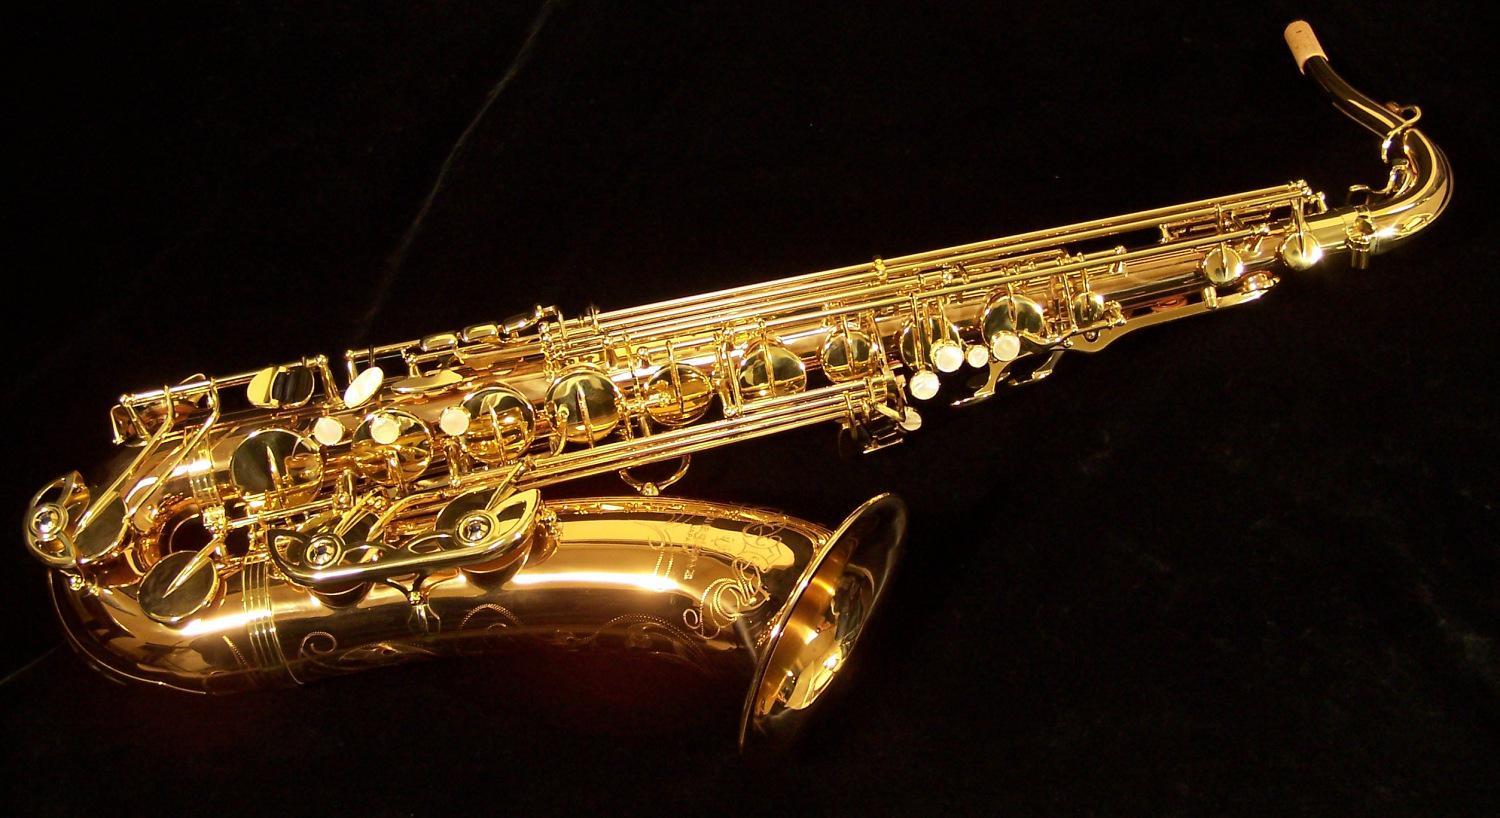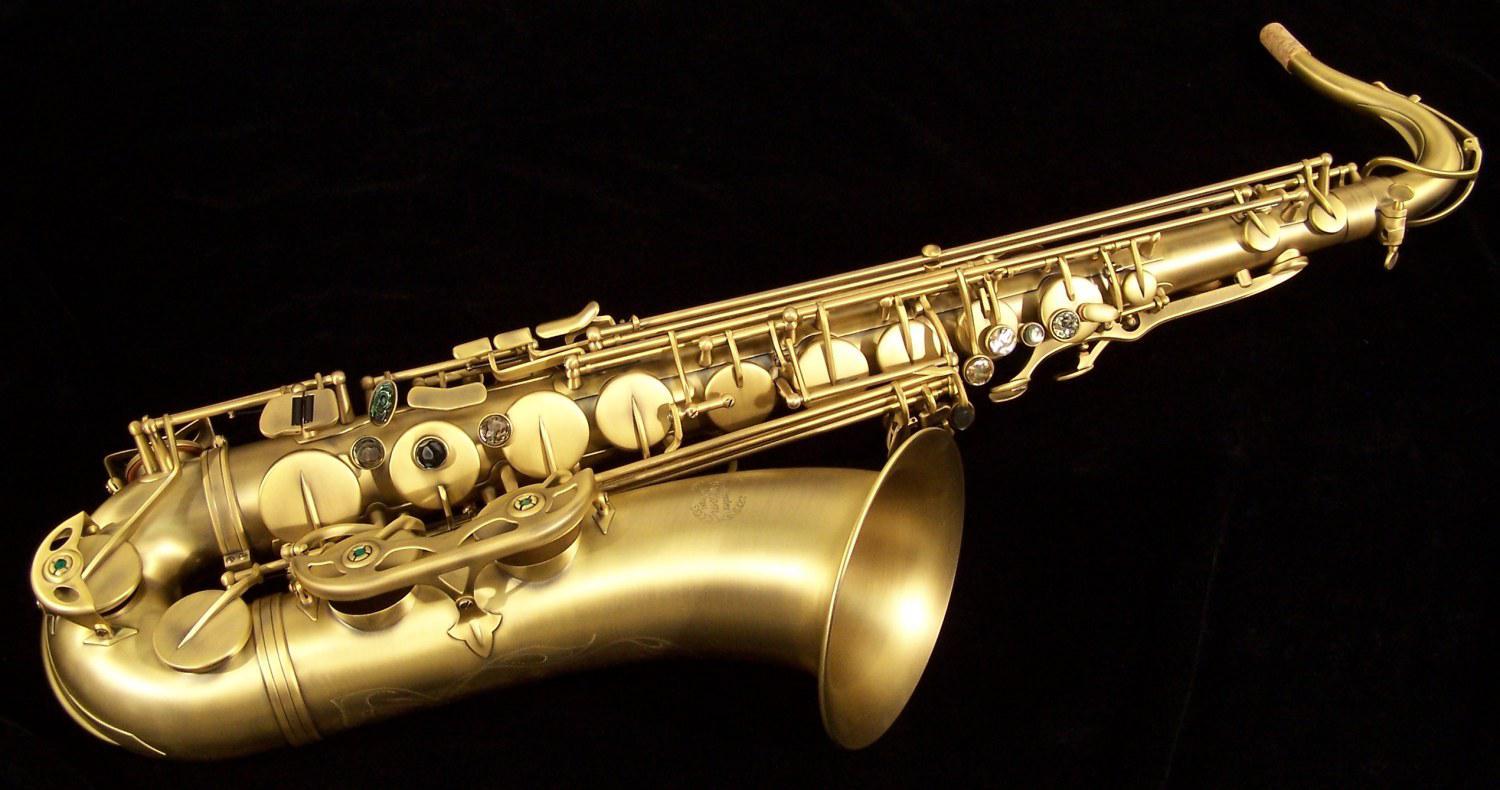The first image is the image on the left, the second image is the image on the right. Examine the images to the left and right. Is the description "Exactly two saxophones the same style, color, and size are positioned at the same angle, horizontal with their bells to the front." accurate? Answer yes or no. Yes. The first image is the image on the left, the second image is the image on the right. Analyze the images presented: Is the assertion "Each image shows one saxophone displayed nearly horizontally, with its bell downward, and all saxophones face the same direction." valid? Answer yes or no. Yes. 